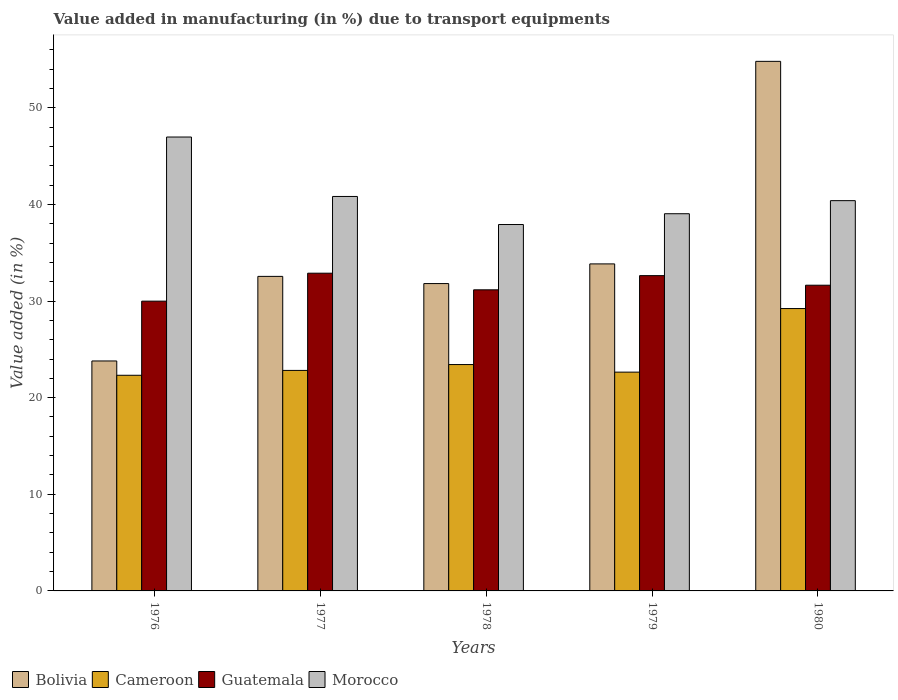How many groups of bars are there?
Keep it short and to the point. 5. Are the number of bars on each tick of the X-axis equal?
Ensure brevity in your answer.  Yes. How many bars are there on the 5th tick from the left?
Provide a succinct answer. 4. What is the percentage of value added in manufacturing due to transport equipments in Cameroon in 1977?
Offer a terse response. 22.82. Across all years, what is the maximum percentage of value added in manufacturing due to transport equipments in Morocco?
Your response must be concise. 46.97. Across all years, what is the minimum percentage of value added in manufacturing due to transport equipments in Cameroon?
Provide a succinct answer. 22.32. In which year was the percentage of value added in manufacturing due to transport equipments in Guatemala minimum?
Give a very brief answer. 1976. What is the total percentage of value added in manufacturing due to transport equipments in Cameroon in the graph?
Keep it short and to the point. 120.43. What is the difference between the percentage of value added in manufacturing due to transport equipments in Guatemala in 1976 and that in 1979?
Provide a short and direct response. -2.64. What is the difference between the percentage of value added in manufacturing due to transport equipments in Cameroon in 1976 and the percentage of value added in manufacturing due to transport equipments in Morocco in 1980?
Keep it short and to the point. -18.07. What is the average percentage of value added in manufacturing due to transport equipments in Morocco per year?
Offer a very short reply. 41.03. In the year 1979, what is the difference between the percentage of value added in manufacturing due to transport equipments in Morocco and percentage of value added in manufacturing due to transport equipments in Bolivia?
Keep it short and to the point. 5.19. In how many years, is the percentage of value added in manufacturing due to transport equipments in Morocco greater than 34 %?
Provide a succinct answer. 5. What is the ratio of the percentage of value added in manufacturing due to transport equipments in Bolivia in 1976 to that in 1977?
Provide a succinct answer. 0.73. Is the percentage of value added in manufacturing due to transport equipments in Morocco in 1976 less than that in 1978?
Your answer should be compact. No. What is the difference between the highest and the second highest percentage of value added in manufacturing due to transport equipments in Guatemala?
Make the answer very short. 0.25. What is the difference between the highest and the lowest percentage of value added in manufacturing due to transport equipments in Bolivia?
Provide a short and direct response. 31.01. In how many years, is the percentage of value added in manufacturing due to transport equipments in Bolivia greater than the average percentage of value added in manufacturing due to transport equipments in Bolivia taken over all years?
Provide a short and direct response. 1. Is it the case that in every year, the sum of the percentage of value added in manufacturing due to transport equipments in Guatemala and percentage of value added in manufacturing due to transport equipments in Cameroon is greater than the sum of percentage of value added in manufacturing due to transport equipments in Bolivia and percentage of value added in manufacturing due to transport equipments in Morocco?
Provide a short and direct response. No. What does the 2nd bar from the left in 1977 represents?
Ensure brevity in your answer.  Cameroon. What does the 2nd bar from the right in 1976 represents?
Provide a succinct answer. Guatemala. Is it the case that in every year, the sum of the percentage of value added in manufacturing due to transport equipments in Cameroon and percentage of value added in manufacturing due to transport equipments in Guatemala is greater than the percentage of value added in manufacturing due to transport equipments in Bolivia?
Ensure brevity in your answer.  Yes. Are all the bars in the graph horizontal?
Make the answer very short. No. Does the graph contain any zero values?
Your answer should be very brief. No. Does the graph contain grids?
Offer a very short reply. No. Where does the legend appear in the graph?
Provide a short and direct response. Bottom left. How many legend labels are there?
Give a very brief answer. 4. How are the legend labels stacked?
Your response must be concise. Horizontal. What is the title of the graph?
Offer a very short reply. Value added in manufacturing (in %) due to transport equipments. What is the label or title of the X-axis?
Your answer should be very brief. Years. What is the label or title of the Y-axis?
Offer a very short reply. Value added (in %). What is the Value added (in %) in Bolivia in 1976?
Provide a succinct answer. 23.8. What is the Value added (in %) in Cameroon in 1976?
Offer a very short reply. 22.32. What is the Value added (in %) in Guatemala in 1976?
Offer a very short reply. 29.99. What is the Value added (in %) in Morocco in 1976?
Ensure brevity in your answer.  46.97. What is the Value added (in %) of Bolivia in 1977?
Provide a short and direct response. 32.55. What is the Value added (in %) in Cameroon in 1977?
Offer a very short reply. 22.82. What is the Value added (in %) of Guatemala in 1977?
Make the answer very short. 32.88. What is the Value added (in %) of Morocco in 1977?
Ensure brevity in your answer.  40.82. What is the Value added (in %) in Bolivia in 1978?
Offer a very short reply. 31.81. What is the Value added (in %) of Cameroon in 1978?
Make the answer very short. 23.43. What is the Value added (in %) in Guatemala in 1978?
Your answer should be very brief. 31.16. What is the Value added (in %) of Morocco in 1978?
Provide a short and direct response. 37.92. What is the Value added (in %) of Bolivia in 1979?
Provide a succinct answer. 33.84. What is the Value added (in %) of Cameroon in 1979?
Give a very brief answer. 22.64. What is the Value added (in %) of Guatemala in 1979?
Your answer should be very brief. 32.63. What is the Value added (in %) of Morocco in 1979?
Keep it short and to the point. 39.04. What is the Value added (in %) in Bolivia in 1980?
Provide a succinct answer. 54.8. What is the Value added (in %) in Cameroon in 1980?
Provide a short and direct response. 29.22. What is the Value added (in %) in Guatemala in 1980?
Offer a very short reply. 31.64. What is the Value added (in %) in Morocco in 1980?
Offer a very short reply. 40.39. Across all years, what is the maximum Value added (in %) of Bolivia?
Your response must be concise. 54.8. Across all years, what is the maximum Value added (in %) of Cameroon?
Make the answer very short. 29.22. Across all years, what is the maximum Value added (in %) in Guatemala?
Ensure brevity in your answer.  32.88. Across all years, what is the maximum Value added (in %) in Morocco?
Keep it short and to the point. 46.97. Across all years, what is the minimum Value added (in %) of Bolivia?
Provide a succinct answer. 23.8. Across all years, what is the minimum Value added (in %) of Cameroon?
Your answer should be compact. 22.32. Across all years, what is the minimum Value added (in %) of Guatemala?
Your answer should be very brief. 29.99. Across all years, what is the minimum Value added (in %) in Morocco?
Keep it short and to the point. 37.92. What is the total Value added (in %) in Bolivia in the graph?
Ensure brevity in your answer.  176.8. What is the total Value added (in %) in Cameroon in the graph?
Give a very brief answer. 120.43. What is the total Value added (in %) of Guatemala in the graph?
Provide a short and direct response. 158.3. What is the total Value added (in %) of Morocco in the graph?
Give a very brief answer. 205.14. What is the difference between the Value added (in %) in Bolivia in 1976 and that in 1977?
Give a very brief answer. -8.75. What is the difference between the Value added (in %) in Cameroon in 1976 and that in 1977?
Make the answer very short. -0.5. What is the difference between the Value added (in %) of Guatemala in 1976 and that in 1977?
Your response must be concise. -2.89. What is the difference between the Value added (in %) in Morocco in 1976 and that in 1977?
Make the answer very short. 6.15. What is the difference between the Value added (in %) in Bolivia in 1976 and that in 1978?
Keep it short and to the point. -8.01. What is the difference between the Value added (in %) in Cameroon in 1976 and that in 1978?
Offer a terse response. -1.11. What is the difference between the Value added (in %) in Guatemala in 1976 and that in 1978?
Keep it short and to the point. -1.17. What is the difference between the Value added (in %) of Morocco in 1976 and that in 1978?
Your response must be concise. 9.05. What is the difference between the Value added (in %) in Bolivia in 1976 and that in 1979?
Offer a very short reply. -10.05. What is the difference between the Value added (in %) in Cameroon in 1976 and that in 1979?
Offer a terse response. -0.33. What is the difference between the Value added (in %) of Guatemala in 1976 and that in 1979?
Give a very brief answer. -2.64. What is the difference between the Value added (in %) of Morocco in 1976 and that in 1979?
Ensure brevity in your answer.  7.94. What is the difference between the Value added (in %) in Bolivia in 1976 and that in 1980?
Your response must be concise. -31.01. What is the difference between the Value added (in %) in Cameroon in 1976 and that in 1980?
Your answer should be compact. -6.9. What is the difference between the Value added (in %) of Guatemala in 1976 and that in 1980?
Make the answer very short. -1.65. What is the difference between the Value added (in %) of Morocco in 1976 and that in 1980?
Offer a terse response. 6.59. What is the difference between the Value added (in %) in Bolivia in 1977 and that in 1978?
Give a very brief answer. 0.74. What is the difference between the Value added (in %) of Cameroon in 1977 and that in 1978?
Offer a terse response. -0.61. What is the difference between the Value added (in %) of Guatemala in 1977 and that in 1978?
Offer a terse response. 1.72. What is the difference between the Value added (in %) in Morocco in 1977 and that in 1978?
Offer a very short reply. 2.9. What is the difference between the Value added (in %) of Bolivia in 1977 and that in 1979?
Offer a very short reply. -1.29. What is the difference between the Value added (in %) in Cameroon in 1977 and that in 1979?
Offer a terse response. 0.18. What is the difference between the Value added (in %) of Guatemala in 1977 and that in 1979?
Offer a terse response. 0.25. What is the difference between the Value added (in %) in Morocco in 1977 and that in 1979?
Your answer should be very brief. 1.79. What is the difference between the Value added (in %) of Bolivia in 1977 and that in 1980?
Ensure brevity in your answer.  -22.25. What is the difference between the Value added (in %) of Cameroon in 1977 and that in 1980?
Provide a short and direct response. -6.4. What is the difference between the Value added (in %) of Guatemala in 1977 and that in 1980?
Make the answer very short. 1.24. What is the difference between the Value added (in %) of Morocco in 1977 and that in 1980?
Provide a succinct answer. 0.43. What is the difference between the Value added (in %) in Bolivia in 1978 and that in 1979?
Ensure brevity in your answer.  -2.03. What is the difference between the Value added (in %) of Cameroon in 1978 and that in 1979?
Provide a succinct answer. 0.78. What is the difference between the Value added (in %) in Guatemala in 1978 and that in 1979?
Make the answer very short. -1.47. What is the difference between the Value added (in %) in Morocco in 1978 and that in 1979?
Your response must be concise. -1.12. What is the difference between the Value added (in %) of Bolivia in 1978 and that in 1980?
Offer a terse response. -23. What is the difference between the Value added (in %) of Cameroon in 1978 and that in 1980?
Your answer should be compact. -5.8. What is the difference between the Value added (in %) of Guatemala in 1978 and that in 1980?
Your answer should be compact. -0.48. What is the difference between the Value added (in %) of Morocco in 1978 and that in 1980?
Make the answer very short. -2.47. What is the difference between the Value added (in %) of Bolivia in 1979 and that in 1980?
Your response must be concise. -20.96. What is the difference between the Value added (in %) in Cameroon in 1979 and that in 1980?
Provide a succinct answer. -6.58. What is the difference between the Value added (in %) in Morocco in 1979 and that in 1980?
Make the answer very short. -1.35. What is the difference between the Value added (in %) of Bolivia in 1976 and the Value added (in %) of Cameroon in 1977?
Your answer should be compact. 0.98. What is the difference between the Value added (in %) of Bolivia in 1976 and the Value added (in %) of Guatemala in 1977?
Keep it short and to the point. -9.08. What is the difference between the Value added (in %) in Bolivia in 1976 and the Value added (in %) in Morocco in 1977?
Your answer should be compact. -17.03. What is the difference between the Value added (in %) in Cameroon in 1976 and the Value added (in %) in Guatemala in 1977?
Your answer should be compact. -10.56. What is the difference between the Value added (in %) in Cameroon in 1976 and the Value added (in %) in Morocco in 1977?
Give a very brief answer. -18.51. What is the difference between the Value added (in %) of Guatemala in 1976 and the Value added (in %) of Morocco in 1977?
Ensure brevity in your answer.  -10.84. What is the difference between the Value added (in %) in Bolivia in 1976 and the Value added (in %) in Cameroon in 1978?
Your answer should be very brief. 0.37. What is the difference between the Value added (in %) of Bolivia in 1976 and the Value added (in %) of Guatemala in 1978?
Your answer should be compact. -7.36. What is the difference between the Value added (in %) in Bolivia in 1976 and the Value added (in %) in Morocco in 1978?
Offer a very short reply. -14.12. What is the difference between the Value added (in %) in Cameroon in 1976 and the Value added (in %) in Guatemala in 1978?
Provide a short and direct response. -8.84. What is the difference between the Value added (in %) of Cameroon in 1976 and the Value added (in %) of Morocco in 1978?
Give a very brief answer. -15.6. What is the difference between the Value added (in %) of Guatemala in 1976 and the Value added (in %) of Morocco in 1978?
Your answer should be compact. -7.93. What is the difference between the Value added (in %) in Bolivia in 1976 and the Value added (in %) in Cameroon in 1979?
Keep it short and to the point. 1.15. What is the difference between the Value added (in %) of Bolivia in 1976 and the Value added (in %) of Guatemala in 1979?
Ensure brevity in your answer.  -8.83. What is the difference between the Value added (in %) of Bolivia in 1976 and the Value added (in %) of Morocco in 1979?
Your answer should be very brief. -15.24. What is the difference between the Value added (in %) in Cameroon in 1976 and the Value added (in %) in Guatemala in 1979?
Offer a terse response. -10.31. What is the difference between the Value added (in %) in Cameroon in 1976 and the Value added (in %) in Morocco in 1979?
Give a very brief answer. -16.72. What is the difference between the Value added (in %) in Guatemala in 1976 and the Value added (in %) in Morocco in 1979?
Ensure brevity in your answer.  -9.05. What is the difference between the Value added (in %) of Bolivia in 1976 and the Value added (in %) of Cameroon in 1980?
Keep it short and to the point. -5.42. What is the difference between the Value added (in %) of Bolivia in 1976 and the Value added (in %) of Guatemala in 1980?
Your answer should be very brief. -7.84. What is the difference between the Value added (in %) in Bolivia in 1976 and the Value added (in %) in Morocco in 1980?
Ensure brevity in your answer.  -16.59. What is the difference between the Value added (in %) of Cameroon in 1976 and the Value added (in %) of Guatemala in 1980?
Ensure brevity in your answer.  -9.32. What is the difference between the Value added (in %) in Cameroon in 1976 and the Value added (in %) in Morocco in 1980?
Offer a very short reply. -18.07. What is the difference between the Value added (in %) in Guatemala in 1976 and the Value added (in %) in Morocco in 1980?
Keep it short and to the point. -10.4. What is the difference between the Value added (in %) of Bolivia in 1977 and the Value added (in %) of Cameroon in 1978?
Offer a terse response. 9.13. What is the difference between the Value added (in %) of Bolivia in 1977 and the Value added (in %) of Guatemala in 1978?
Ensure brevity in your answer.  1.39. What is the difference between the Value added (in %) in Bolivia in 1977 and the Value added (in %) in Morocco in 1978?
Provide a short and direct response. -5.37. What is the difference between the Value added (in %) of Cameroon in 1977 and the Value added (in %) of Guatemala in 1978?
Keep it short and to the point. -8.34. What is the difference between the Value added (in %) of Cameroon in 1977 and the Value added (in %) of Morocco in 1978?
Make the answer very short. -15.1. What is the difference between the Value added (in %) of Guatemala in 1977 and the Value added (in %) of Morocco in 1978?
Your answer should be compact. -5.04. What is the difference between the Value added (in %) in Bolivia in 1977 and the Value added (in %) in Cameroon in 1979?
Offer a very short reply. 9.91. What is the difference between the Value added (in %) of Bolivia in 1977 and the Value added (in %) of Guatemala in 1979?
Your answer should be compact. -0.08. What is the difference between the Value added (in %) of Bolivia in 1977 and the Value added (in %) of Morocco in 1979?
Offer a very short reply. -6.48. What is the difference between the Value added (in %) of Cameroon in 1977 and the Value added (in %) of Guatemala in 1979?
Your answer should be compact. -9.81. What is the difference between the Value added (in %) of Cameroon in 1977 and the Value added (in %) of Morocco in 1979?
Your answer should be compact. -16.21. What is the difference between the Value added (in %) in Guatemala in 1977 and the Value added (in %) in Morocco in 1979?
Ensure brevity in your answer.  -6.15. What is the difference between the Value added (in %) of Bolivia in 1977 and the Value added (in %) of Cameroon in 1980?
Your answer should be compact. 3.33. What is the difference between the Value added (in %) of Bolivia in 1977 and the Value added (in %) of Guatemala in 1980?
Offer a terse response. 0.91. What is the difference between the Value added (in %) of Bolivia in 1977 and the Value added (in %) of Morocco in 1980?
Make the answer very short. -7.84. What is the difference between the Value added (in %) of Cameroon in 1977 and the Value added (in %) of Guatemala in 1980?
Offer a terse response. -8.82. What is the difference between the Value added (in %) of Cameroon in 1977 and the Value added (in %) of Morocco in 1980?
Provide a succinct answer. -17.57. What is the difference between the Value added (in %) of Guatemala in 1977 and the Value added (in %) of Morocco in 1980?
Make the answer very short. -7.51. What is the difference between the Value added (in %) of Bolivia in 1978 and the Value added (in %) of Cameroon in 1979?
Provide a succinct answer. 9.17. What is the difference between the Value added (in %) of Bolivia in 1978 and the Value added (in %) of Guatemala in 1979?
Your response must be concise. -0.82. What is the difference between the Value added (in %) in Bolivia in 1978 and the Value added (in %) in Morocco in 1979?
Keep it short and to the point. -7.23. What is the difference between the Value added (in %) in Cameroon in 1978 and the Value added (in %) in Guatemala in 1979?
Your answer should be compact. -9.2. What is the difference between the Value added (in %) of Cameroon in 1978 and the Value added (in %) of Morocco in 1979?
Your answer should be compact. -15.61. What is the difference between the Value added (in %) of Guatemala in 1978 and the Value added (in %) of Morocco in 1979?
Give a very brief answer. -7.87. What is the difference between the Value added (in %) of Bolivia in 1978 and the Value added (in %) of Cameroon in 1980?
Provide a succinct answer. 2.59. What is the difference between the Value added (in %) in Bolivia in 1978 and the Value added (in %) in Guatemala in 1980?
Keep it short and to the point. 0.17. What is the difference between the Value added (in %) of Bolivia in 1978 and the Value added (in %) of Morocco in 1980?
Keep it short and to the point. -8.58. What is the difference between the Value added (in %) of Cameroon in 1978 and the Value added (in %) of Guatemala in 1980?
Offer a very short reply. -8.21. What is the difference between the Value added (in %) of Cameroon in 1978 and the Value added (in %) of Morocco in 1980?
Keep it short and to the point. -16.96. What is the difference between the Value added (in %) in Guatemala in 1978 and the Value added (in %) in Morocco in 1980?
Your answer should be very brief. -9.23. What is the difference between the Value added (in %) in Bolivia in 1979 and the Value added (in %) in Cameroon in 1980?
Make the answer very short. 4.62. What is the difference between the Value added (in %) in Bolivia in 1979 and the Value added (in %) in Guatemala in 1980?
Make the answer very short. 2.21. What is the difference between the Value added (in %) of Bolivia in 1979 and the Value added (in %) of Morocco in 1980?
Ensure brevity in your answer.  -6.55. What is the difference between the Value added (in %) in Cameroon in 1979 and the Value added (in %) in Guatemala in 1980?
Offer a terse response. -8.99. What is the difference between the Value added (in %) of Cameroon in 1979 and the Value added (in %) of Morocco in 1980?
Offer a terse response. -17.75. What is the difference between the Value added (in %) of Guatemala in 1979 and the Value added (in %) of Morocco in 1980?
Your response must be concise. -7.76. What is the average Value added (in %) of Bolivia per year?
Your answer should be compact. 35.36. What is the average Value added (in %) of Cameroon per year?
Your answer should be very brief. 24.09. What is the average Value added (in %) of Guatemala per year?
Give a very brief answer. 31.66. What is the average Value added (in %) in Morocco per year?
Your answer should be compact. 41.03. In the year 1976, what is the difference between the Value added (in %) in Bolivia and Value added (in %) in Cameroon?
Give a very brief answer. 1.48. In the year 1976, what is the difference between the Value added (in %) in Bolivia and Value added (in %) in Guatemala?
Keep it short and to the point. -6.19. In the year 1976, what is the difference between the Value added (in %) of Bolivia and Value added (in %) of Morocco?
Your answer should be very brief. -23.18. In the year 1976, what is the difference between the Value added (in %) of Cameroon and Value added (in %) of Guatemala?
Provide a short and direct response. -7.67. In the year 1976, what is the difference between the Value added (in %) of Cameroon and Value added (in %) of Morocco?
Offer a terse response. -24.66. In the year 1976, what is the difference between the Value added (in %) of Guatemala and Value added (in %) of Morocco?
Make the answer very short. -16.99. In the year 1977, what is the difference between the Value added (in %) in Bolivia and Value added (in %) in Cameroon?
Provide a short and direct response. 9.73. In the year 1977, what is the difference between the Value added (in %) of Bolivia and Value added (in %) of Guatemala?
Provide a short and direct response. -0.33. In the year 1977, what is the difference between the Value added (in %) of Bolivia and Value added (in %) of Morocco?
Offer a terse response. -8.27. In the year 1977, what is the difference between the Value added (in %) of Cameroon and Value added (in %) of Guatemala?
Your answer should be compact. -10.06. In the year 1977, what is the difference between the Value added (in %) of Cameroon and Value added (in %) of Morocco?
Ensure brevity in your answer.  -18. In the year 1977, what is the difference between the Value added (in %) in Guatemala and Value added (in %) in Morocco?
Provide a short and direct response. -7.94. In the year 1978, what is the difference between the Value added (in %) in Bolivia and Value added (in %) in Cameroon?
Provide a short and direct response. 8.38. In the year 1978, what is the difference between the Value added (in %) of Bolivia and Value added (in %) of Guatemala?
Keep it short and to the point. 0.65. In the year 1978, what is the difference between the Value added (in %) of Bolivia and Value added (in %) of Morocco?
Your answer should be very brief. -6.11. In the year 1978, what is the difference between the Value added (in %) of Cameroon and Value added (in %) of Guatemala?
Make the answer very short. -7.74. In the year 1978, what is the difference between the Value added (in %) in Cameroon and Value added (in %) in Morocco?
Give a very brief answer. -14.49. In the year 1978, what is the difference between the Value added (in %) of Guatemala and Value added (in %) of Morocco?
Offer a very short reply. -6.76. In the year 1979, what is the difference between the Value added (in %) of Bolivia and Value added (in %) of Cameroon?
Ensure brevity in your answer.  11.2. In the year 1979, what is the difference between the Value added (in %) in Bolivia and Value added (in %) in Guatemala?
Your answer should be very brief. 1.21. In the year 1979, what is the difference between the Value added (in %) of Bolivia and Value added (in %) of Morocco?
Offer a terse response. -5.19. In the year 1979, what is the difference between the Value added (in %) in Cameroon and Value added (in %) in Guatemala?
Keep it short and to the point. -9.99. In the year 1979, what is the difference between the Value added (in %) of Cameroon and Value added (in %) of Morocco?
Your answer should be very brief. -16.39. In the year 1979, what is the difference between the Value added (in %) in Guatemala and Value added (in %) in Morocco?
Give a very brief answer. -6.41. In the year 1980, what is the difference between the Value added (in %) in Bolivia and Value added (in %) in Cameroon?
Your answer should be compact. 25.58. In the year 1980, what is the difference between the Value added (in %) in Bolivia and Value added (in %) in Guatemala?
Offer a very short reply. 23.17. In the year 1980, what is the difference between the Value added (in %) in Bolivia and Value added (in %) in Morocco?
Your response must be concise. 14.42. In the year 1980, what is the difference between the Value added (in %) in Cameroon and Value added (in %) in Guatemala?
Your response must be concise. -2.42. In the year 1980, what is the difference between the Value added (in %) of Cameroon and Value added (in %) of Morocco?
Make the answer very short. -11.17. In the year 1980, what is the difference between the Value added (in %) in Guatemala and Value added (in %) in Morocco?
Give a very brief answer. -8.75. What is the ratio of the Value added (in %) of Bolivia in 1976 to that in 1977?
Provide a succinct answer. 0.73. What is the ratio of the Value added (in %) in Cameroon in 1976 to that in 1977?
Keep it short and to the point. 0.98. What is the ratio of the Value added (in %) of Guatemala in 1976 to that in 1977?
Provide a short and direct response. 0.91. What is the ratio of the Value added (in %) of Morocco in 1976 to that in 1977?
Make the answer very short. 1.15. What is the ratio of the Value added (in %) in Bolivia in 1976 to that in 1978?
Your response must be concise. 0.75. What is the ratio of the Value added (in %) of Cameroon in 1976 to that in 1978?
Offer a very short reply. 0.95. What is the ratio of the Value added (in %) in Guatemala in 1976 to that in 1978?
Give a very brief answer. 0.96. What is the ratio of the Value added (in %) in Morocco in 1976 to that in 1978?
Offer a terse response. 1.24. What is the ratio of the Value added (in %) of Bolivia in 1976 to that in 1979?
Keep it short and to the point. 0.7. What is the ratio of the Value added (in %) in Cameroon in 1976 to that in 1979?
Provide a succinct answer. 0.99. What is the ratio of the Value added (in %) in Guatemala in 1976 to that in 1979?
Your answer should be very brief. 0.92. What is the ratio of the Value added (in %) in Morocco in 1976 to that in 1979?
Offer a very short reply. 1.2. What is the ratio of the Value added (in %) of Bolivia in 1976 to that in 1980?
Provide a succinct answer. 0.43. What is the ratio of the Value added (in %) of Cameroon in 1976 to that in 1980?
Offer a very short reply. 0.76. What is the ratio of the Value added (in %) of Guatemala in 1976 to that in 1980?
Provide a short and direct response. 0.95. What is the ratio of the Value added (in %) of Morocco in 1976 to that in 1980?
Keep it short and to the point. 1.16. What is the ratio of the Value added (in %) in Bolivia in 1977 to that in 1978?
Provide a short and direct response. 1.02. What is the ratio of the Value added (in %) in Cameroon in 1977 to that in 1978?
Offer a terse response. 0.97. What is the ratio of the Value added (in %) of Guatemala in 1977 to that in 1978?
Provide a succinct answer. 1.06. What is the ratio of the Value added (in %) in Morocco in 1977 to that in 1978?
Ensure brevity in your answer.  1.08. What is the ratio of the Value added (in %) of Bolivia in 1977 to that in 1979?
Your response must be concise. 0.96. What is the ratio of the Value added (in %) of Cameroon in 1977 to that in 1979?
Your response must be concise. 1.01. What is the ratio of the Value added (in %) in Guatemala in 1977 to that in 1979?
Keep it short and to the point. 1.01. What is the ratio of the Value added (in %) in Morocco in 1977 to that in 1979?
Your response must be concise. 1.05. What is the ratio of the Value added (in %) of Bolivia in 1977 to that in 1980?
Offer a very short reply. 0.59. What is the ratio of the Value added (in %) in Cameroon in 1977 to that in 1980?
Make the answer very short. 0.78. What is the ratio of the Value added (in %) in Guatemala in 1977 to that in 1980?
Offer a very short reply. 1.04. What is the ratio of the Value added (in %) of Morocco in 1977 to that in 1980?
Your answer should be very brief. 1.01. What is the ratio of the Value added (in %) of Bolivia in 1978 to that in 1979?
Provide a succinct answer. 0.94. What is the ratio of the Value added (in %) in Cameroon in 1978 to that in 1979?
Give a very brief answer. 1.03. What is the ratio of the Value added (in %) in Guatemala in 1978 to that in 1979?
Make the answer very short. 0.95. What is the ratio of the Value added (in %) in Morocco in 1978 to that in 1979?
Make the answer very short. 0.97. What is the ratio of the Value added (in %) of Bolivia in 1978 to that in 1980?
Give a very brief answer. 0.58. What is the ratio of the Value added (in %) in Cameroon in 1978 to that in 1980?
Provide a succinct answer. 0.8. What is the ratio of the Value added (in %) of Guatemala in 1978 to that in 1980?
Ensure brevity in your answer.  0.98. What is the ratio of the Value added (in %) of Morocco in 1978 to that in 1980?
Offer a terse response. 0.94. What is the ratio of the Value added (in %) of Bolivia in 1979 to that in 1980?
Your response must be concise. 0.62. What is the ratio of the Value added (in %) of Cameroon in 1979 to that in 1980?
Make the answer very short. 0.77. What is the ratio of the Value added (in %) in Guatemala in 1979 to that in 1980?
Make the answer very short. 1.03. What is the ratio of the Value added (in %) of Morocco in 1979 to that in 1980?
Ensure brevity in your answer.  0.97. What is the difference between the highest and the second highest Value added (in %) of Bolivia?
Ensure brevity in your answer.  20.96. What is the difference between the highest and the second highest Value added (in %) of Cameroon?
Ensure brevity in your answer.  5.8. What is the difference between the highest and the second highest Value added (in %) in Guatemala?
Offer a very short reply. 0.25. What is the difference between the highest and the second highest Value added (in %) of Morocco?
Give a very brief answer. 6.15. What is the difference between the highest and the lowest Value added (in %) in Bolivia?
Make the answer very short. 31.01. What is the difference between the highest and the lowest Value added (in %) of Cameroon?
Offer a very short reply. 6.9. What is the difference between the highest and the lowest Value added (in %) in Guatemala?
Give a very brief answer. 2.89. What is the difference between the highest and the lowest Value added (in %) of Morocco?
Your answer should be compact. 9.05. 